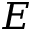Convert formula to latex. <formula><loc_0><loc_0><loc_500><loc_500>E</formula> 